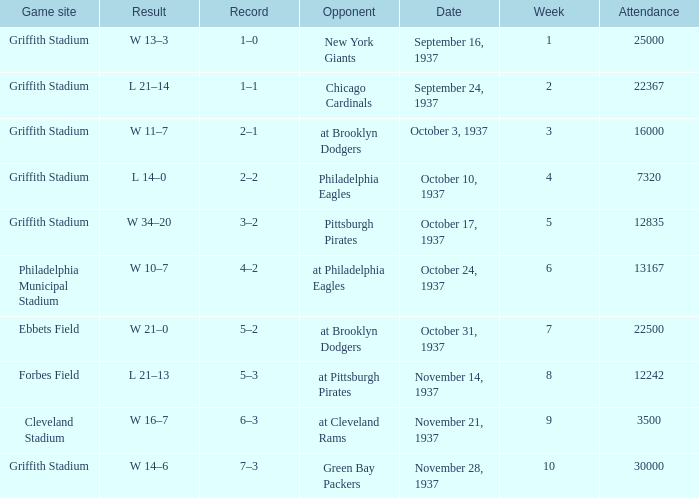On October 17, 1937 what was maximum number or attendants. 12835.0. 